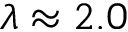<formula> <loc_0><loc_0><loc_500><loc_500>\lambda \approx 2 . 0</formula> 